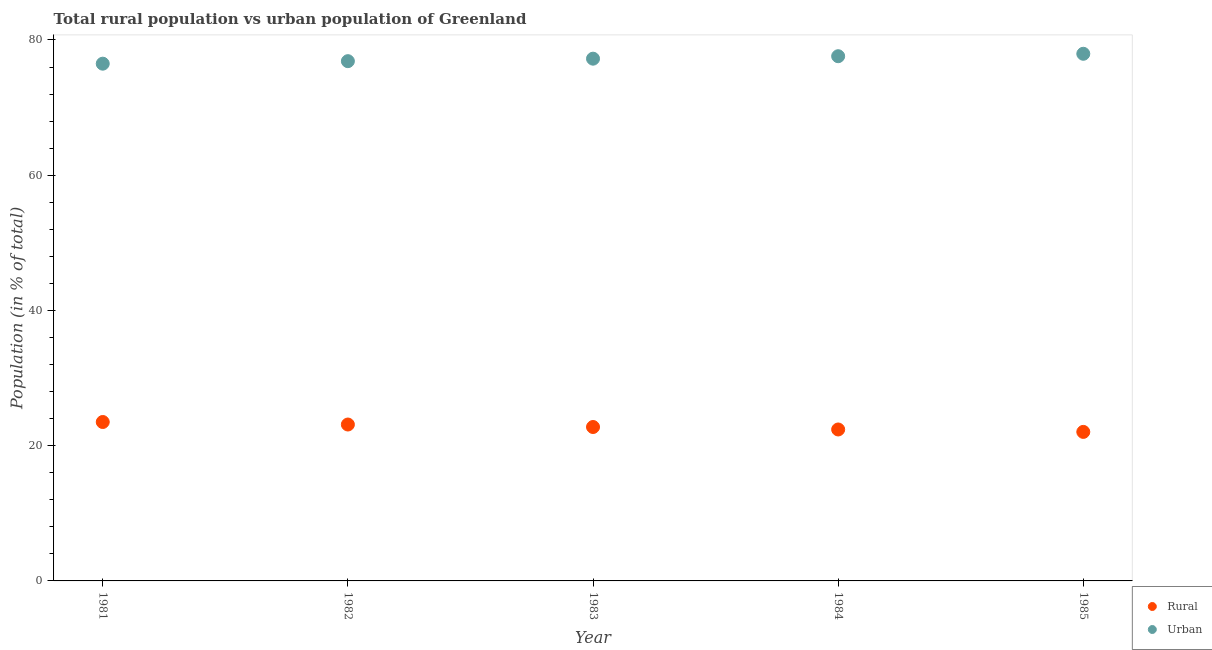How many different coloured dotlines are there?
Your response must be concise. 2. What is the rural population in 1981?
Offer a very short reply. 23.5. Across all years, what is the maximum rural population?
Your answer should be very brief. 23.5. Across all years, what is the minimum rural population?
Your answer should be compact. 22.04. In which year was the rural population maximum?
Make the answer very short. 1981. What is the total rural population in the graph?
Your answer should be compact. 113.83. What is the difference between the rural population in 1982 and that in 1983?
Make the answer very short. 0.37. What is the difference between the urban population in 1982 and the rural population in 1984?
Keep it short and to the point. 54.47. What is the average urban population per year?
Your response must be concise. 77.23. In the year 1982, what is the difference between the rural population and urban population?
Your answer should be very brief. -53.74. What is the ratio of the urban population in 1981 to that in 1983?
Give a very brief answer. 0.99. Is the urban population in 1981 less than that in 1985?
Make the answer very short. Yes. Is the difference between the rural population in 1982 and 1983 greater than the difference between the urban population in 1982 and 1983?
Your response must be concise. Yes. What is the difference between the highest and the second highest urban population?
Make the answer very short. 0.36. What is the difference between the highest and the lowest urban population?
Provide a short and direct response. 1.46. In how many years, is the urban population greater than the average urban population taken over all years?
Keep it short and to the point. 3. Is the sum of the urban population in 1981 and 1985 greater than the maximum rural population across all years?
Make the answer very short. Yes. Is the rural population strictly greater than the urban population over the years?
Keep it short and to the point. No. Is the urban population strictly less than the rural population over the years?
Your answer should be compact. No. What is the difference between two consecutive major ticks on the Y-axis?
Keep it short and to the point. 20. Does the graph contain grids?
Your answer should be very brief. No. Where does the legend appear in the graph?
Provide a succinct answer. Bottom right. What is the title of the graph?
Make the answer very short. Total rural population vs urban population of Greenland. Does "Gasoline" appear as one of the legend labels in the graph?
Keep it short and to the point. No. What is the label or title of the X-axis?
Your answer should be very brief. Year. What is the label or title of the Y-axis?
Ensure brevity in your answer.  Population (in % of total). What is the Population (in % of total) in Rural in 1981?
Give a very brief answer. 23.5. What is the Population (in % of total) of Urban in 1981?
Keep it short and to the point. 76.5. What is the Population (in % of total) in Rural in 1982?
Your response must be concise. 23.13. What is the Population (in % of total) of Urban in 1982?
Provide a short and direct response. 76.87. What is the Population (in % of total) of Rural in 1983?
Offer a terse response. 22.76. What is the Population (in % of total) in Urban in 1983?
Your response must be concise. 77.24. What is the Population (in % of total) of Rural in 1984?
Your response must be concise. 22.4. What is the Population (in % of total) in Urban in 1984?
Offer a very short reply. 77.6. What is the Population (in % of total) of Rural in 1985?
Provide a short and direct response. 22.04. What is the Population (in % of total) of Urban in 1985?
Give a very brief answer. 77.96. Across all years, what is the maximum Population (in % of total) of Rural?
Ensure brevity in your answer.  23.5. Across all years, what is the maximum Population (in % of total) of Urban?
Keep it short and to the point. 77.96. Across all years, what is the minimum Population (in % of total) of Rural?
Provide a short and direct response. 22.04. Across all years, what is the minimum Population (in % of total) of Urban?
Your answer should be very brief. 76.5. What is the total Population (in % of total) in Rural in the graph?
Keep it short and to the point. 113.83. What is the total Population (in % of total) of Urban in the graph?
Your answer should be compact. 386.17. What is the difference between the Population (in % of total) in Rural in 1981 and that in 1982?
Your answer should be very brief. 0.37. What is the difference between the Population (in % of total) in Urban in 1981 and that in 1982?
Keep it short and to the point. -0.37. What is the difference between the Population (in % of total) of Rural in 1981 and that in 1983?
Offer a terse response. 0.74. What is the difference between the Population (in % of total) in Urban in 1981 and that in 1983?
Your answer should be very brief. -0.74. What is the difference between the Population (in % of total) of Rural in 1981 and that in 1984?
Offer a very short reply. 1.1. What is the difference between the Population (in % of total) of Urban in 1981 and that in 1984?
Ensure brevity in your answer.  -1.1. What is the difference between the Population (in % of total) of Rural in 1981 and that in 1985?
Provide a succinct answer. 1.46. What is the difference between the Population (in % of total) of Urban in 1981 and that in 1985?
Provide a succinct answer. -1.46. What is the difference between the Population (in % of total) of Rural in 1982 and that in 1983?
Provide a succinct answer. 0.37. What is the difference between the Population (in % of total) of Urban in 1982 and that in 1983?
Provide a short and direct response. -0.37. What is the difference between the Population (in % of total) of Rural in 1982 and that in 1984?
Make the answer very short. 0.73. What is the difference between the Population (in % of total) of Urban in 1982 and that in 1984?
Give a very brief answer. -0.73. What is the difference between the Population (in % of total) in Rural in 1982 and that in 1985?
Give a very brief answer. 1.09. What is the difference between the Population (in % of total) in Urban in 1982 and that in 1985?
Your response must be concise. -1.09. What is the difference between the Population (in % of total) of Rural in 1983 and that in 1984?
Make the answer very short. 0.36. What is the difference between the Population (in % of total) in Urban in 1983 and that in 1984?
Provide a succinct answer. -0.36. What is the difference between the Population (in % of total) in Rural in 1983 and that in 1985?
Offer a very short reply. 0.72. What is the difference between the Population (in % of total) of Urban in 1983 and that in 1985?
Ensure brevity in your answer.  -0.72. What is the difference between the Population (in % of total) of Rural in 1984 and that in 1985?
Offer a very short reply. 0.36. What is the difference between the Population (in % of total) of Urban in 1984 and that in 1985?
Provide a succinct answer. -0.36. What is the difference between the Population (in % of total) in Rural in 1981 and the Population (in % of total) in Urban in 1982?
Provide a short and direct response. -53.37. What is the difference between the Population (in % of total) in Rural in 1981 and the Population (in % of total) in Urban in 1983?
Your response must be concise. -53.73. What is the difference between the Population (in % of total) of Rural in 1981 and the Population (in % of total) of Urban in 1984?
Offer a very short reply. -54.1. What is the difference between the Population (in % of total) of Rural in 1981 and the Population (in % of total) of Urban in 1985?
Your response must be concise. -54.46. What is the difference between the Population (in % of total) of Rural in 1982 and the Population (in % of total) of Urban in 1983?
Offer a very short reply. -54.11. What is the difference between the Population (in % of total) in Rural in 1982 and the Population (in % of total) in Urban in 1984?
Keep it short and to the point. -54.47. What is the difference between the Population (in % of total) of Rural in 1982 and the Population (in % of total) of Urban in 1985?
Offer a terse response. -54.83. What is the difference between the Population (in % of total) of Rural in 1983 and the Population (in % of total) of Urban in 1984?
Your answer should be compact. -54.84. What is the difference between the Population (in % of total) of Rural in 1983 and the Population (in % of total) of Urban in 1985?
Give a very brief answer. -55.2. What is the difference between the Population (in % of total) of Rural in 1984 and the Population (in % of total) of Urban in 1985?
Your answer should be compact. -55.56. What is the average Population (in % of total) in Rural per year?
Ensure brevity in your answer.  22.77. What is the average Population (in % of total) in Urban per year?
Make the answer very short. 77.23. In the year 1981, what is the difference between the Population (in % of total) of Rural and Population (in % of total) of Urban?
Keep it short and to the point. -52.99. In the year 1982, what is the difference between the Population (in % of total) of Rural and Population (in % of total) of Urban?
Ensure brevity in your answer.  -53.74. In the year 1983, what is the difference between the Population (in % of total) of Rural and Population (in % of total) of Urban?
Give a very brief answer. -54.47. In the year 1984, what is the difference between the Population (in % of total) of Rural and Population (in % of total) of Urban?
Provide a short and direct response. -55.2. In the year 1985, what is the difference between the Population (in % of total) of Rural and Population (in % of total) of Urban?
Offer a terse response. -55.92. What is the ratio of the Population (in % of total) in Rural in 1981 to that in 1982?
Give a very brief answer. 1.02. What is the ratio of the Population (in % of total) in Rural in 1981 to that in 1983?
Offer a terse response. 1.03. What is the ratio of the Population (in % of total) in Rural in 1981 to that in 1984?
Your response must be concise. 1.05. What is the ratio of the Population (in % of total) of Urban in 1981 to that in 1984?
Offer a terse response. 0.99. What is the ratio of the Population (in % of total) in Rural in 1981 to that in 1985?
Offer a terse response. 1.07. What is the ratio of the Population (in % of total) of Urban in 1981 to that in 1985?
Offer a very short reply. 0.98. What is the ratio of the Population (in % of total) of Rural in 1982 to that in 1983?
Make the answer very short. 1.02. What is the ratio of the Population (in % of total) of Urban in 1982 to that in 1983?
Make the answer very short. 1. What is the ratio of the Population (in % of total) in Rural in 1982 to that in 1984?
Provide a short and direct response. 1.03. What is the ratio of the Population (in % of total) of Urban in 1982 to that in 1984?
Offer a terse response. 0.99. What is the ratio of the Population (in % of total) of Rural in 1982 to that in 1985?
Give a very brief answer. 1.05. What is the ratio of the Population (in % of total) in Rural in 1983 to that in 1984?
Offer a very short reply. 1.02. What is the ratio of the Population (in % of total) of Urban in 1983 to that in 1984?
Your answer should be very brief. 1. What is the ratio of the Population (in % of total) of Rural in 1983 to that in 1985?
Offer a very short reply. 1.03. What is the ratio of the Population (in % of total) in Rural in 1984 to that in 1985?
Offer a very short reply. 1.02. What is the ratio of the Population (in % of total) of Urban in 1984 to that in 1985?
Your response must be concise. 1. What is the difference between the highest and the second highest Population (in % of total) of Rural?
Your response must be concise. 0.37. What is the difference between the highest and the second highest Population (in % of total) of Urban?
Provide a short and direct response. 0.36. What is the difference between the highest and the lowest Population (in % of total) in Rural?
Provide a short and direct response. 1.46. What is the difference between the highest and the lowest Population (in % of total) of Urban?
Ensure brevity in your answer.  1.46. 